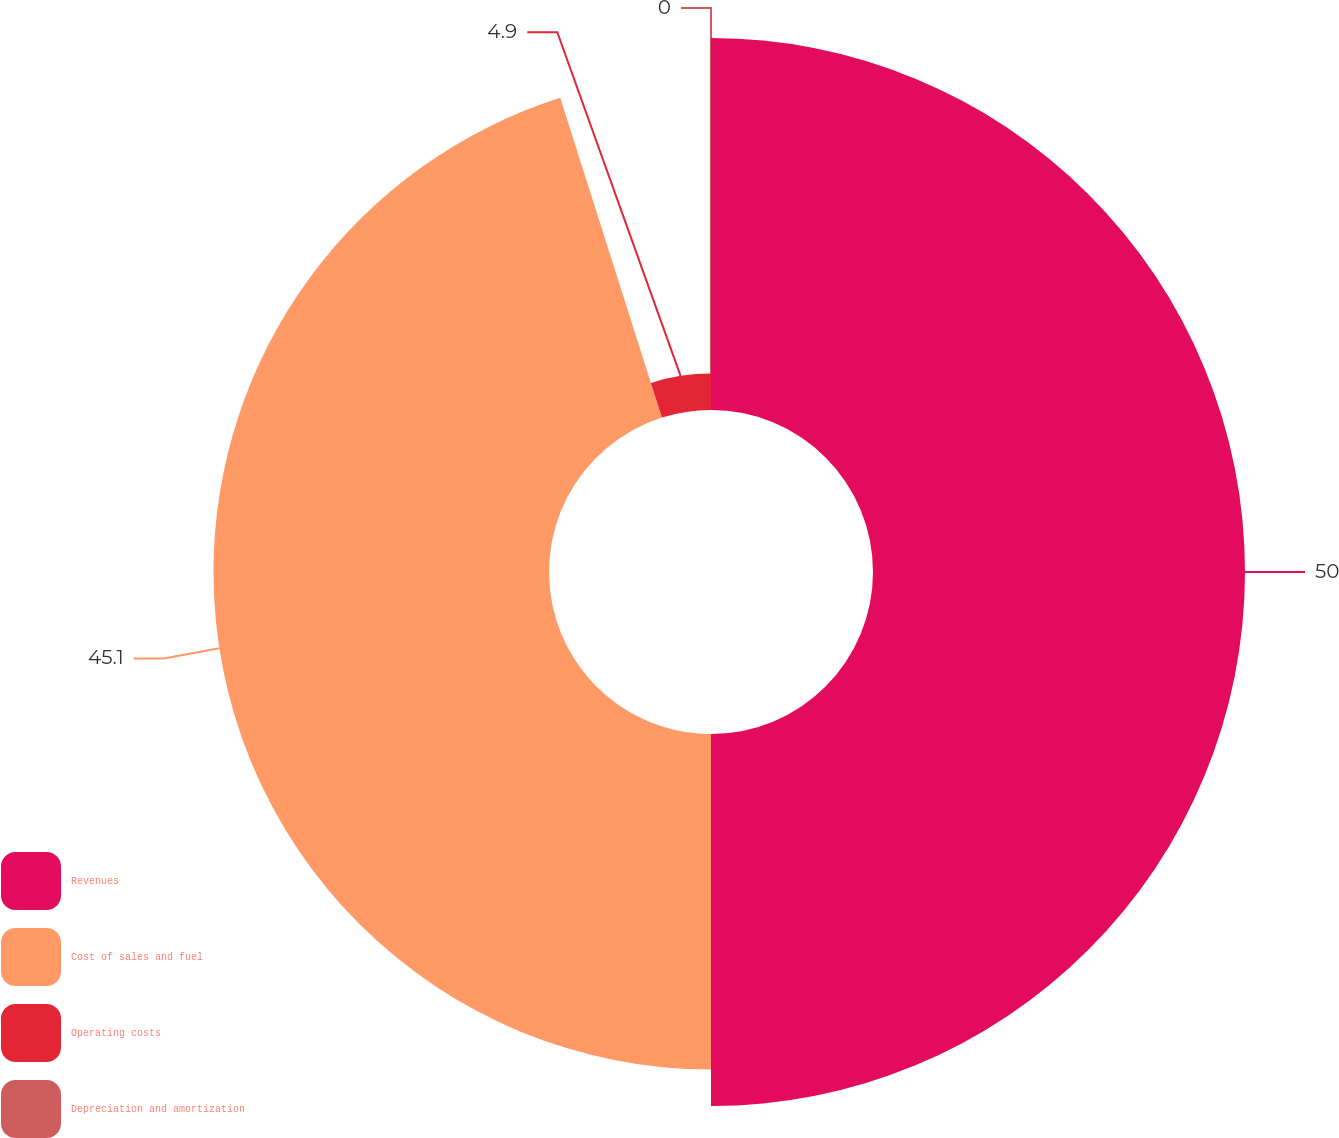Convert chart. <chart><loc_0><loc_0><loc_500><loc_500><pie_chart><fcel>Revenues<fcel>Cost of sales and fuel<fcel>Operating costs<fcel>Depreciation and amortization<nl><fcel>50.0%<fcel>45.1%<fcel>4.9%<fcel>0.0%<nl></chart> 